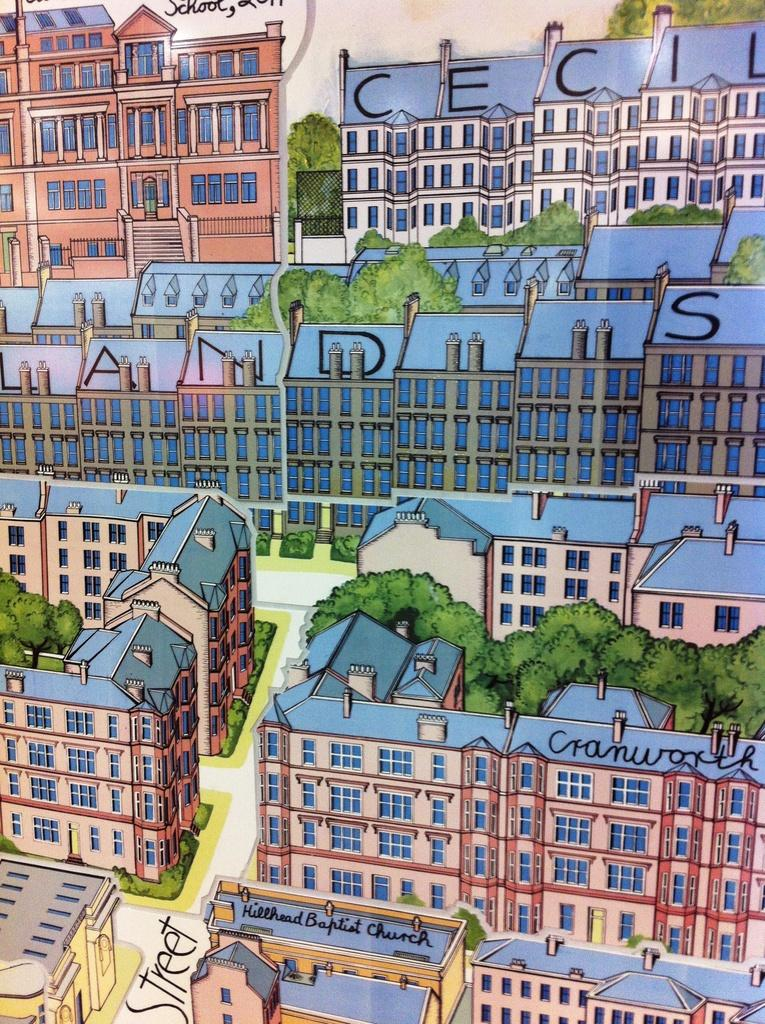What is the main subject of the image? There is an art piece in the image. What elements are included in the art piece? The art piece contains roads, buildings, and trees. Is there any text present in the image? Yes, there is text written in the image. What can be seen in the background of the image? The sky is visible in the background of the image. How many units of rock are present in the image? There is no rock present in the image; it features an art piece with roads, buildings, and trees. What type of receipt can be seen in the image? There is no receipt present in the image. 